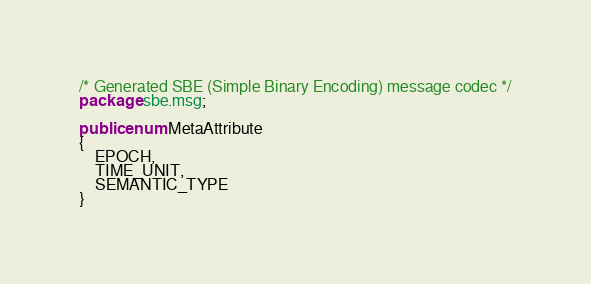Convert code to text. <code><loc_0><loc_0><loc_500><loc_500><_Java_>/* Generated SBE (Simple Binary Encoding) message codec */
package sbe.msg;

public enum MetaAttribute
{
    EPOCH,
    TIME_UNIT,
    SEMANTIC_TYPE
}
</code> 